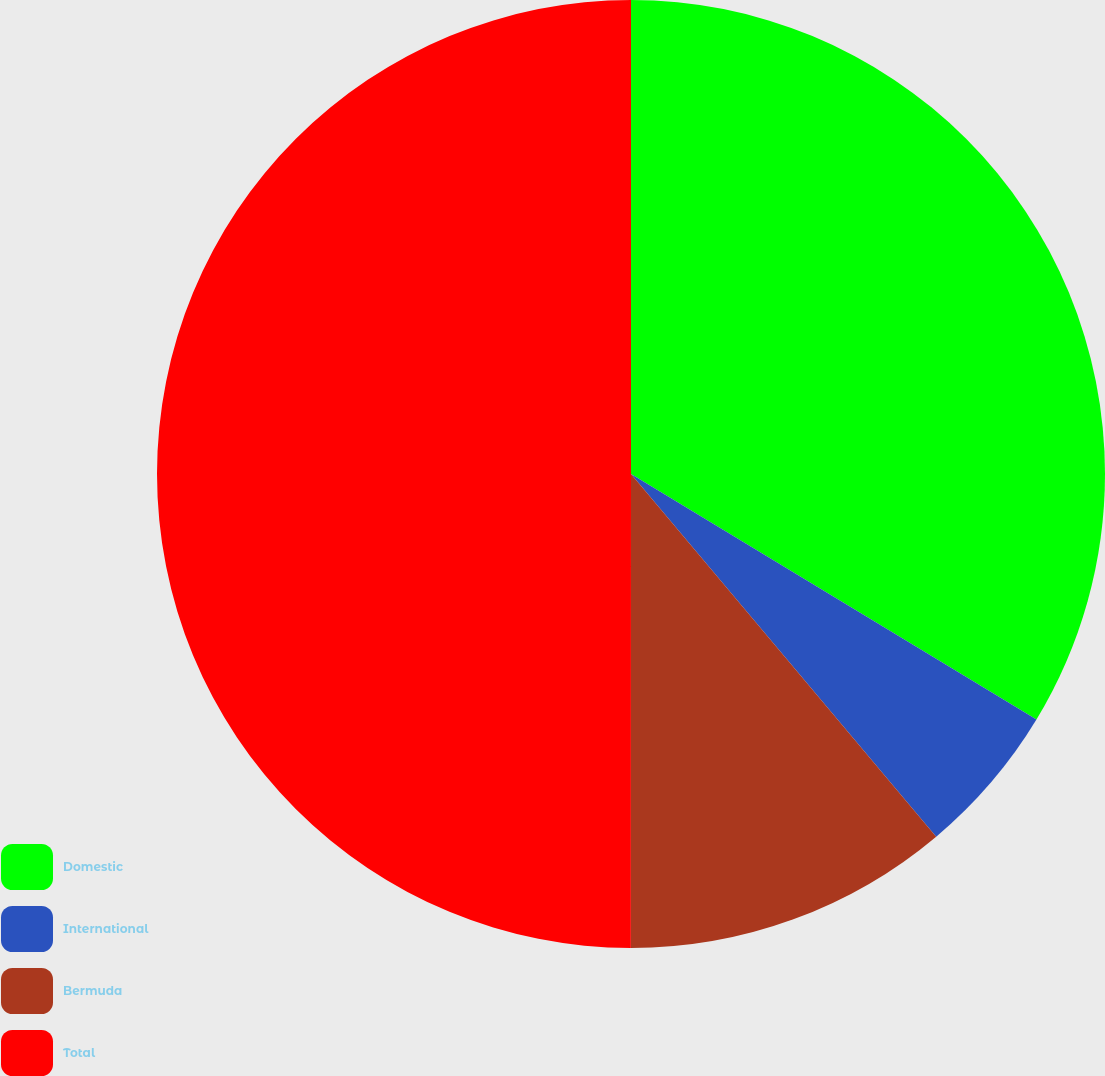Convert chart to OTSL. <chart><loc_0><loc_0><loc_500><loc_500><pie_chart><fcel>Domestic<fcel>International<fcel>Bermuda<fcel>Total<nl><fcel>33.67%<fcel>5.2%<fcel>11.14%<fcel>50.0%<nl></chart> 